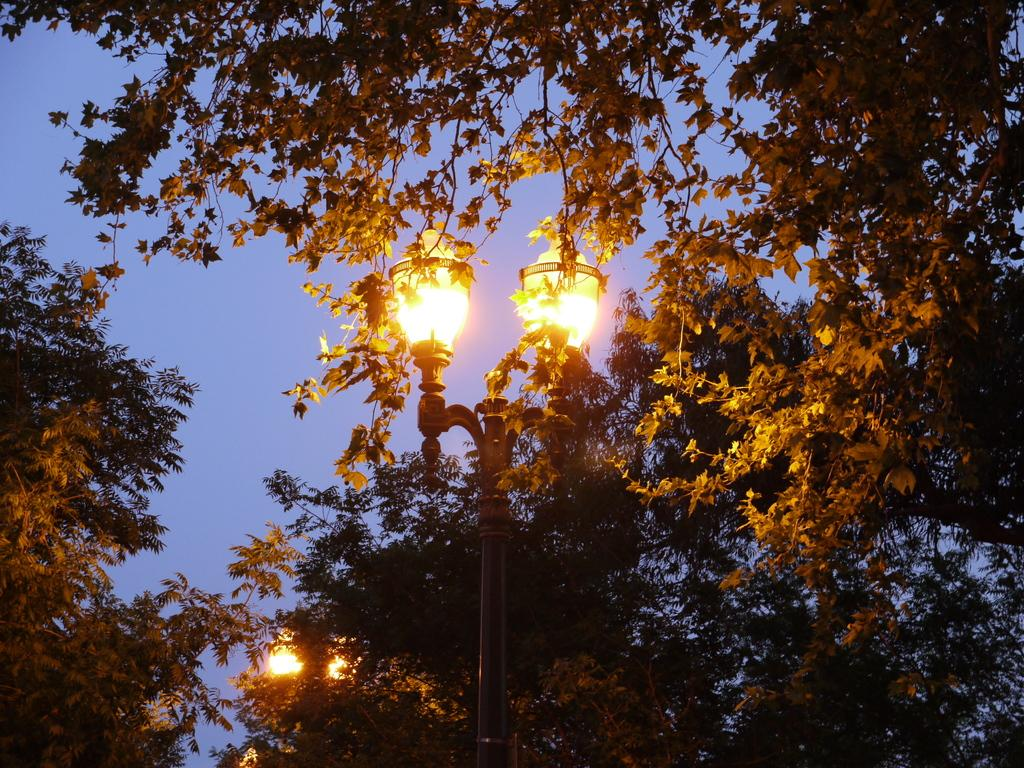What type of vegetation can be seen in the image? There are trees in the image. What colors are the trees? The trees are green and yellow in color. What else is present in the image besides the trees? There is a pole in the image. How many lights are at the top of the pole? There are two lights at the top of the pole. What can be seen in the background of the image? The sky is visible in the background of the image. What type of canvas is being used to learn about debt in the image? There is no canvas or reference to learning about debt in the image; it features trees, a pole with lights, and a visible sky. 